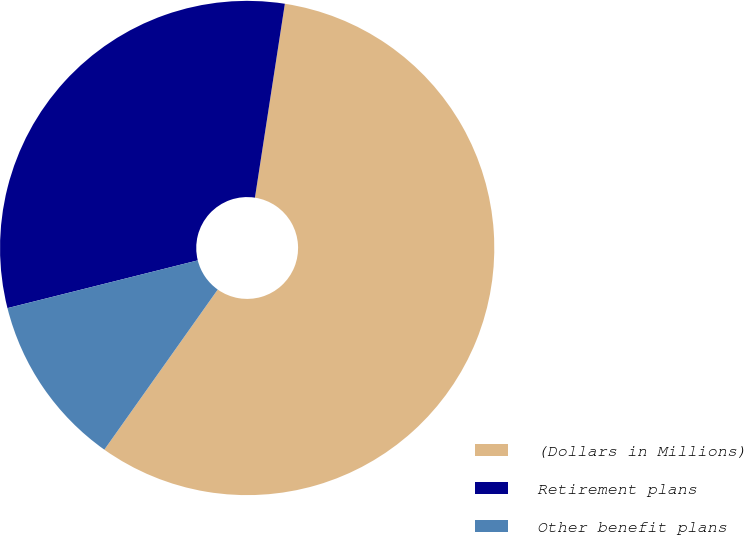<chart> <loc_0><loc_0><loc_500><loc_500><pie_chart><fcel>(Dollars in Millions)<fcel>Retirement plans<fcel>Other benefit plans<nl><fcel>57.37%<fcel>31.35%<fcel>11.28%<nl></chart> 